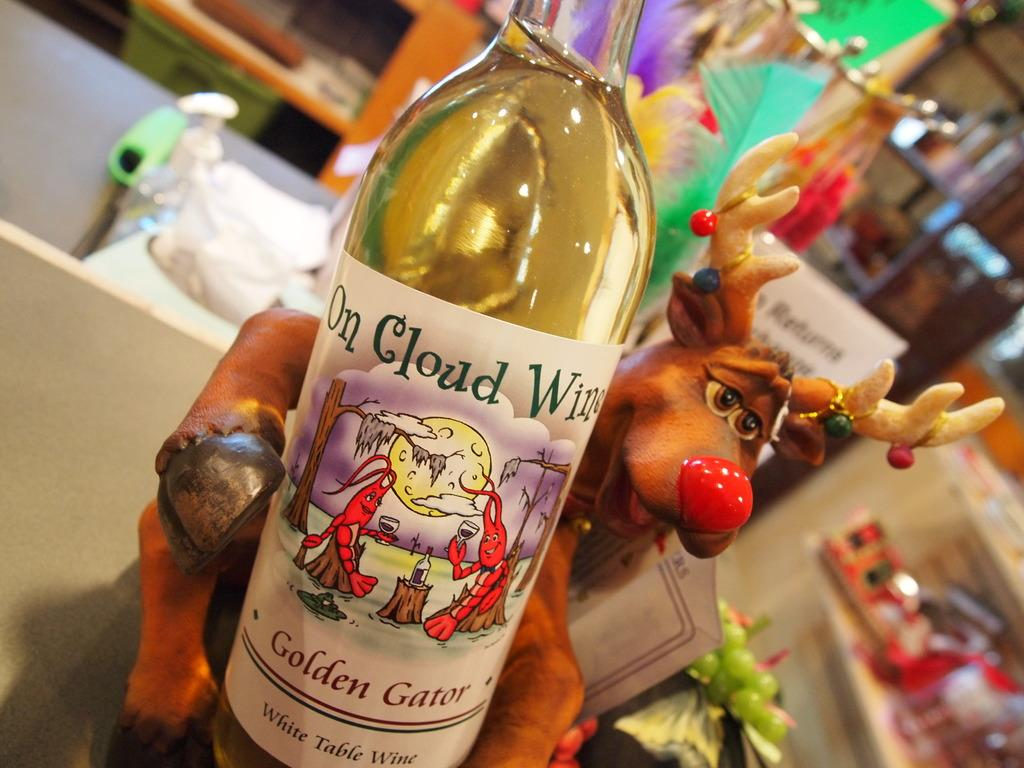What is on the table in the image? There is a bottle with a label on the table in the image. What is located behind the bottle? There is a toy behind the bottle. What type of toys can be seen in the background of the image? There are toy grapes and feathers in the background of the image. What type of furniture is visible in the background of the image? There are cupboards in the background of the image. Can you see a rifle on the table in the image? No, there is no rifle present in the image. 